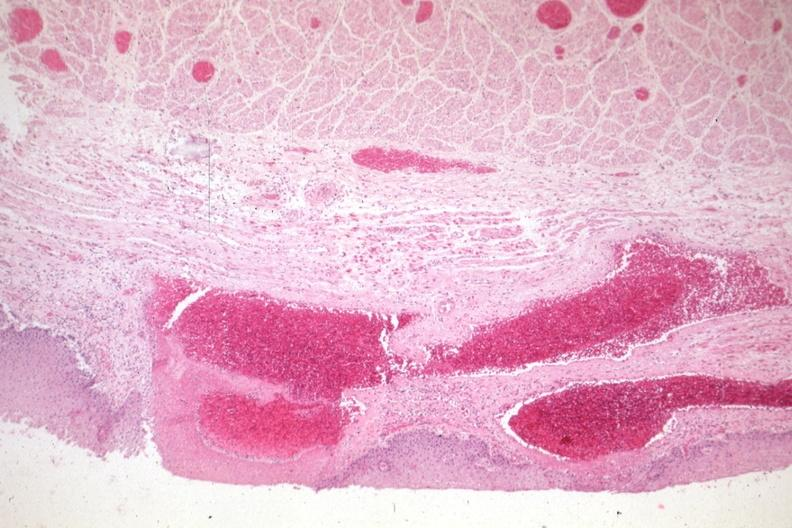what does this image show?
Answer the question using a single word or phrase. Good example of varices 